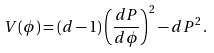<formula> <loc_0><loc_0><loc_500><loc_500>V ( \phi ) = ( d - 1 ) \left ( \frac { d P } { d \phi } \right ) ^ { 2 } - d P ^ { 2 } \, .</formula> 